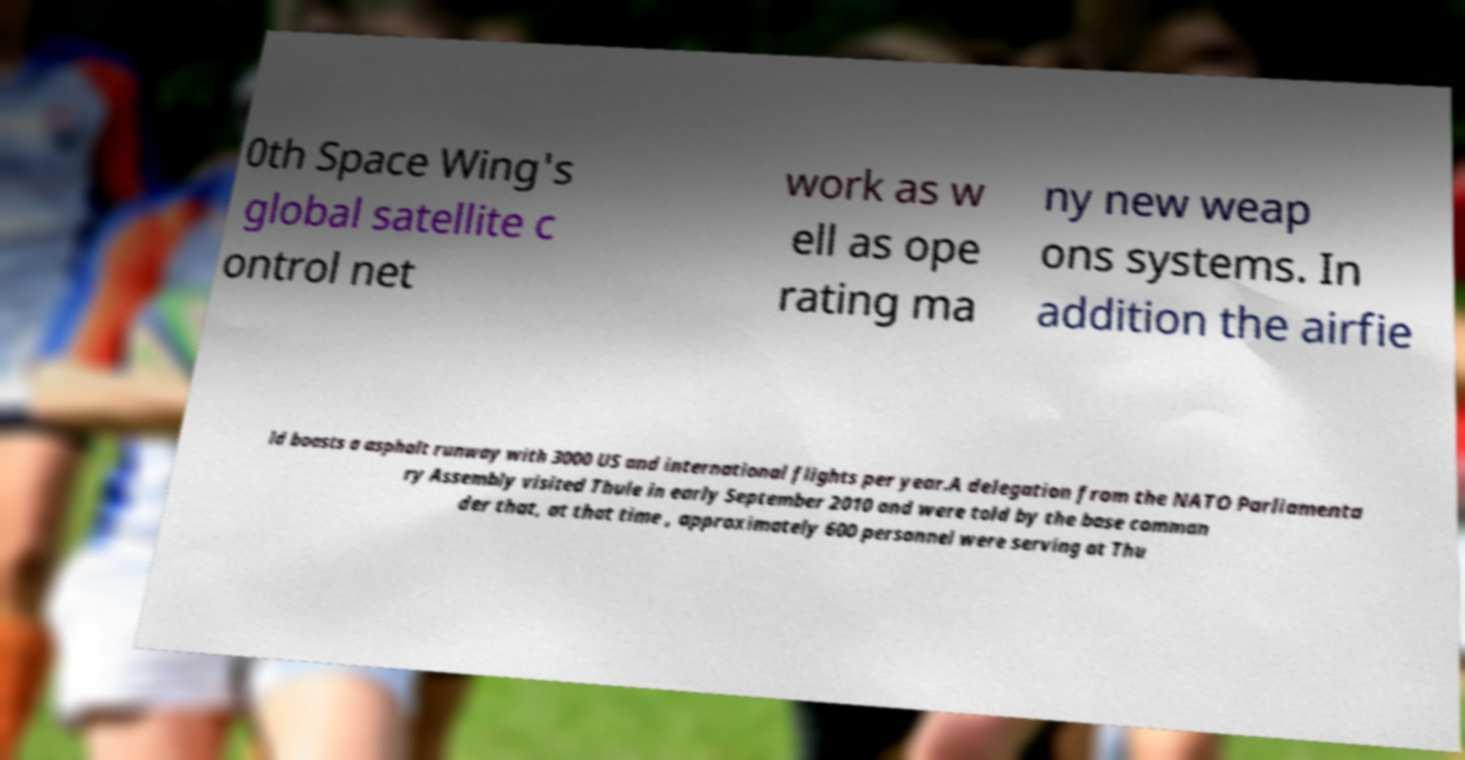Please read and relay the text visible in this image. What does it say? 0th Space Wing's global satellite c ontrol net work as w ell as ope rating ma ny new weap ons systems. In addition the airfie ld boasts a asphalt runway with 3000 US and international flights per year.A delegation from the NATO Parliamenta ry Assembly visited Thule in early September 2010 and were told by the base comman der that, at that time , approximately 600 personnel were serving at Thu 